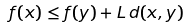<formula> <loc_0><loc_0><loc_500><loc_500>f ( x ) \leq f ( y ) + L \, d ( x , y )</formula> 